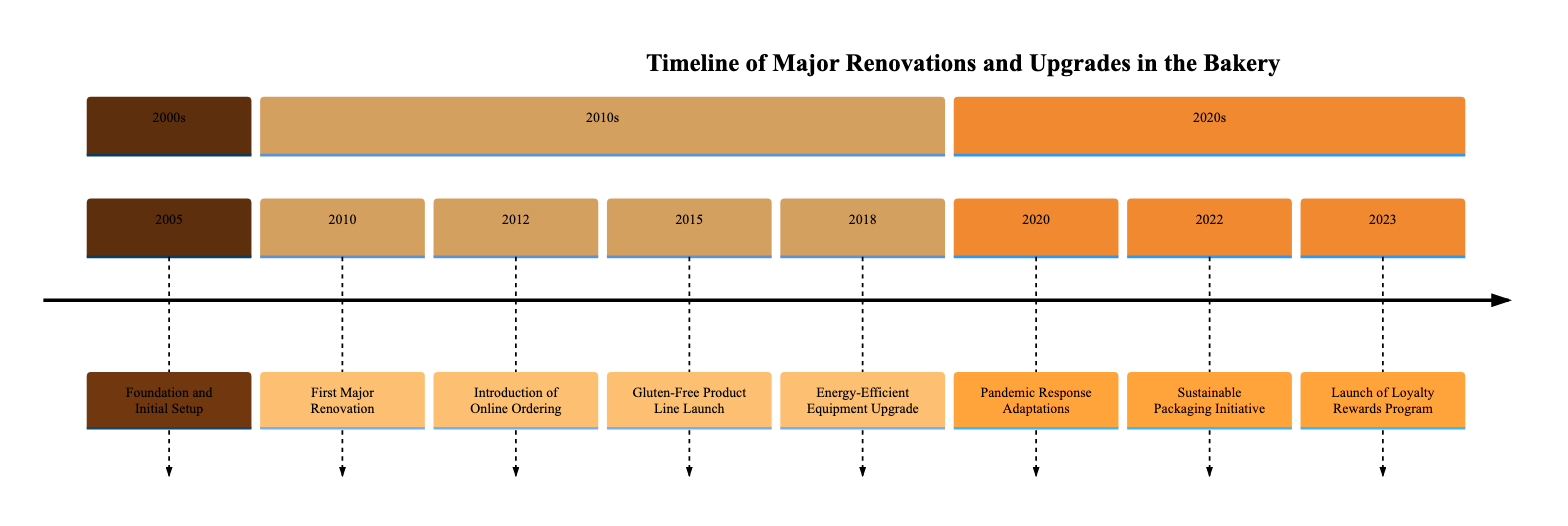What year was the bakery established? According to the timeline, the event related to the establishment of the bakery is labeled as "Foundation and Initial Setup," which occurs in the year 2005.
Answer: 2005 What major renovation occurred in 2010? In 2010, the first major renovation is described as a "Facility upgrade including new ovens and increased seating capacity." This can be found by looking at the event listed for that year.
Answer: First Major Renovation How many major renovations are listed in the timeline? By reviewing the timeline, there are 4 events categorized as major renovations: in 2010, 2015, 2018, and 2020, which leads to a total of 4 major renovations.
Answer: 4 What initiative was introduced in 2022? Referring to the event for the year 2022, it states "Sustainable Packaging Initiative." This indicates the specific initiative that took place in that year.
Answer: Sustainable Packaging Initiative What upgrade was made in 2018? In 2018, the event is described as "Energy-Efficient Equipment Upgrade," which provides information about the specific upgrade that occurred at that time.
Answer: Energy-Efficient Equipment Upgrade Which year followed the introduction of online ordering? The introduction of online ordering took place in 2012, and the following event listed is the "Gluten-Free Product Line Launch" in 2015, indicating the year that comes next in the timeline.
Answer: 2015 What response adaptations were made during the pandemic? The timeline indicates that in 2020, the bakery implemented "contactless delivery and curbside pickup options," detailing the adaptations made during the pandemic.
Answer: contactless delivery and curbside pickup options What was the trend leading to the launch of a gluten-free product line? The event for 2015 indicates the bakery expanded its menu "responding to customer demands and dietary trends" which implies this trend influenced the launch of the gluten-free product line.
Answer: customer demands and dietary trends 